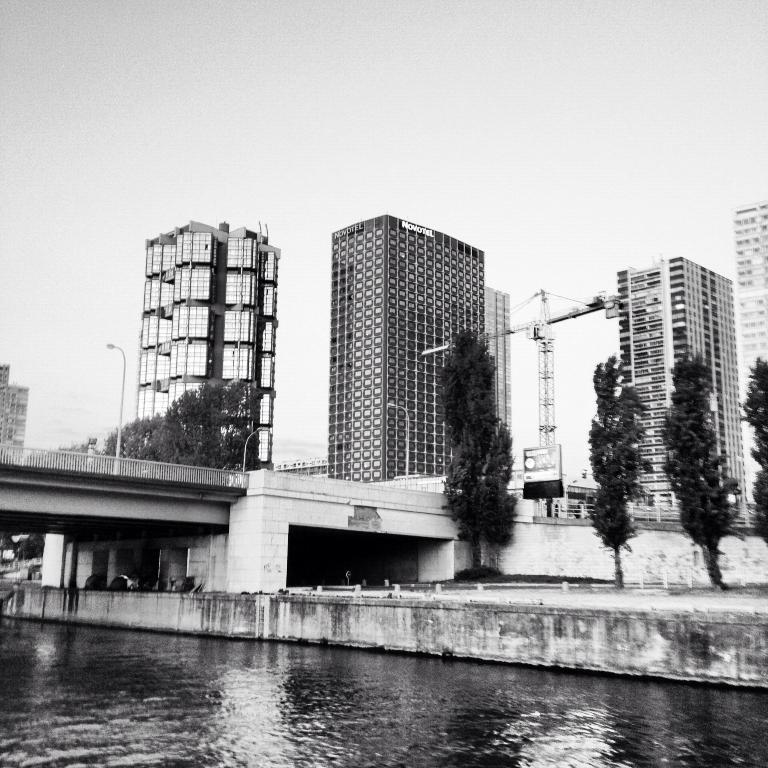What is one of the natural elements present in the image? There is water in the image. What type of vegetation can be seen in the image? There are trees in the image. What structure is present in the image that allows people to cross the water? There is a bridge in the image. What feature of the bridge is mentioned in the facts? Lights are present on the bridge. What type of man-made structures can be seen in the image? There are buildings in the image. What is visible in the background of the image? The sky is visible in the background of the image. What type of chicken is being represented by the lights on the bridge? There is no chicken present in the image, nor are the lights on the bridge meant to represent a chicken. 